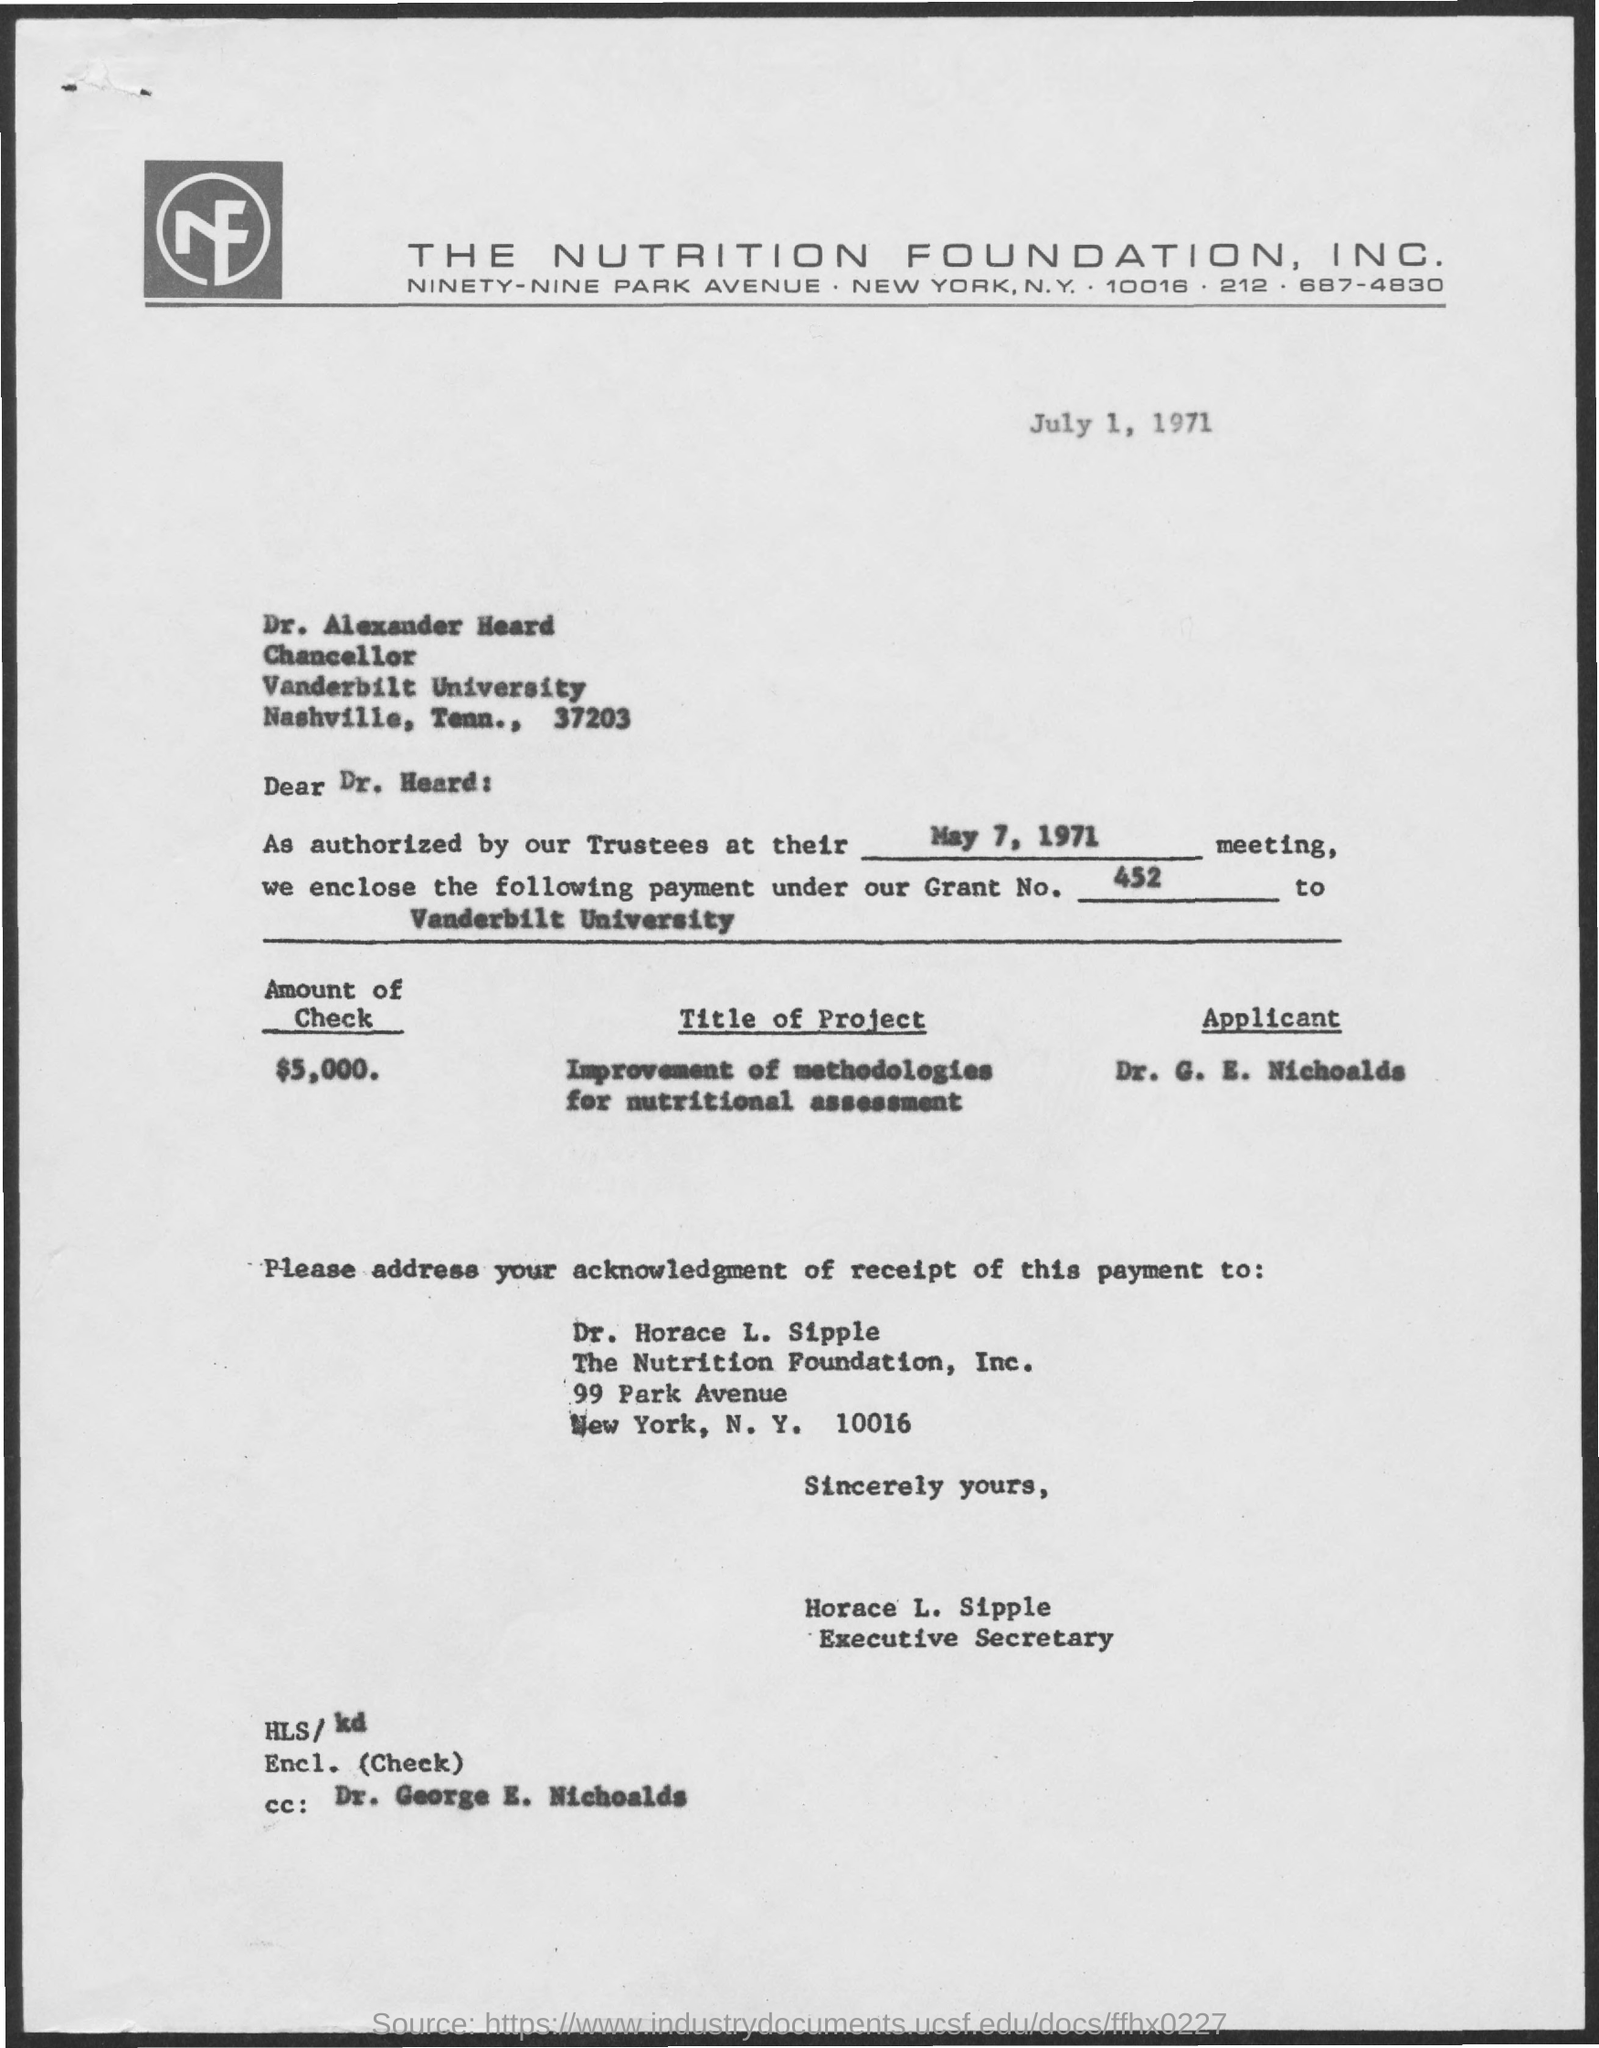What is the amount of check mentioned in this document?
Offer a terse response. $5,000. What is the issued date of this document?
Your answer should be very brief. July 1, 1971. 